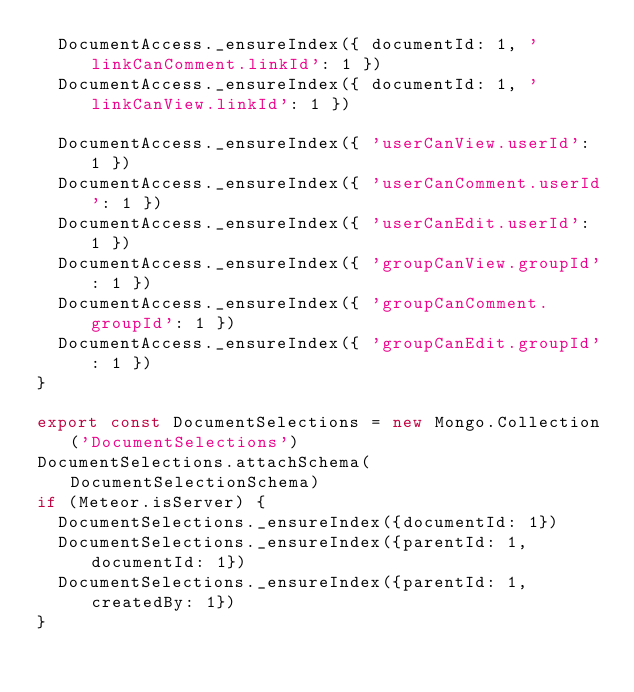Convert code to text. <code><loc_0><loc_0><loc_500><loc_500><_JavaScript_>  DocumentAccess._ensureIndex({ documentId: 1, 'linkCanComment.linkId': 1 })
  DocumentAccess._ensureIndex({ documentId: 1, 'linkCanView.linkId': 1 })

  DocumentAccess._ensureIndex({ 'userCanView.userId': 1 })
  DocumentAccess._ensureIndex({ 'userCanComment.userId': 1 })
  DocumentAccess._ensureIndex({ 'userCanEdit.userId': 1 })
  DocumentAccess._ensureIndex({ 'groupCanView.groupId': 1 })
  DocumentAccess._ensureIndex({ 'groupCanComment.groupId': 1 })
  DocumentAccess._ensureIndex({ 'groupCanEdit.groupId': 1 })
}

export const DocumentSelections = new Mongo.Collection('DocumentSelections')
DocumentSelections.attachSchema(DocumentSelectionSchema)
if (Meteor.isServer) {
  DocumentSelections._ensureIndex({documentId: 1})
  DocumentSelections._ensureIndex({parentId: 1, documentId: 1})
  DocumentSelections._ensureIndex({parentId: 1, createdBy: 1})
}
</code> 